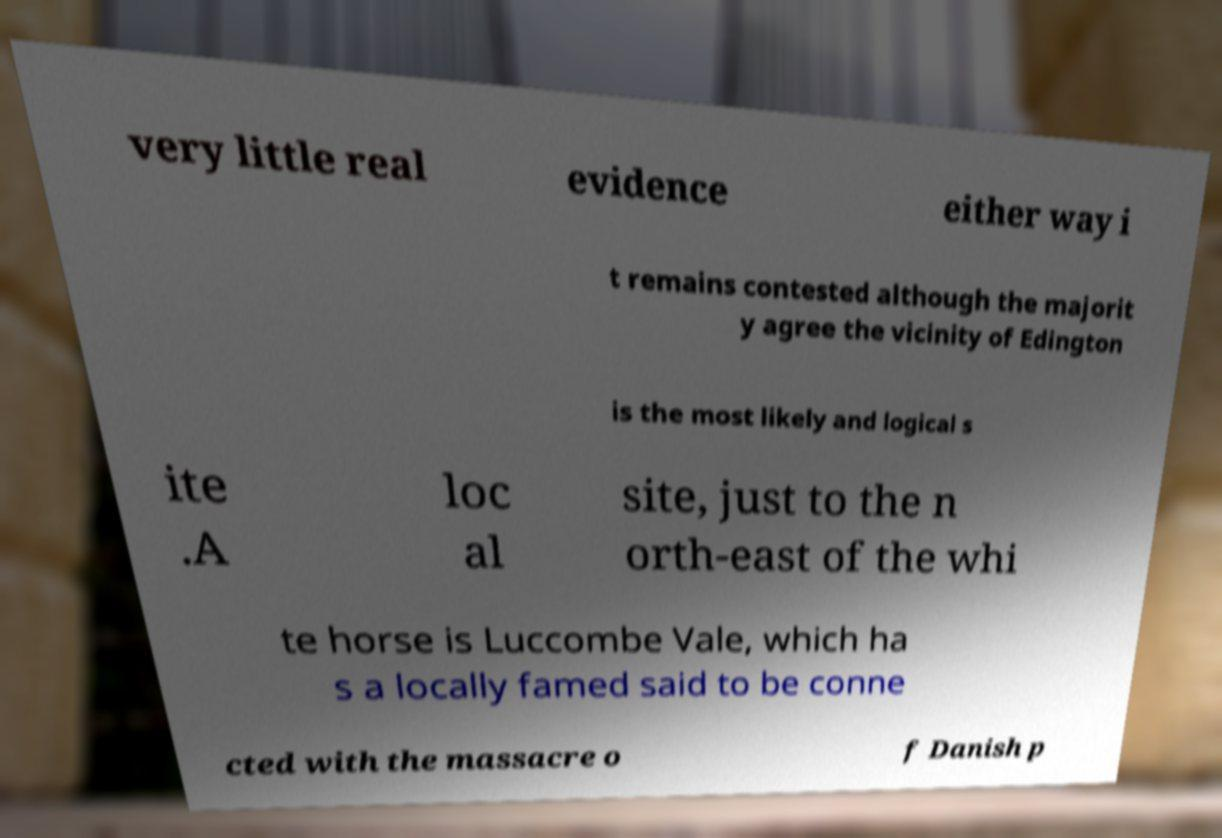Can you read and provide the text displayed in the image?This photo seems to have some interesting text. Can you extract and type it out for me? very little real evidence either way i t remains contested although the majorit y agree the vicinity of Edington is the most likely and logical s ite .A loc al site, just to the n orth-east of the whi te horse is Luccombe Vale, which ha s a locally famed said to be conne cted with the massacre o f Danish p 